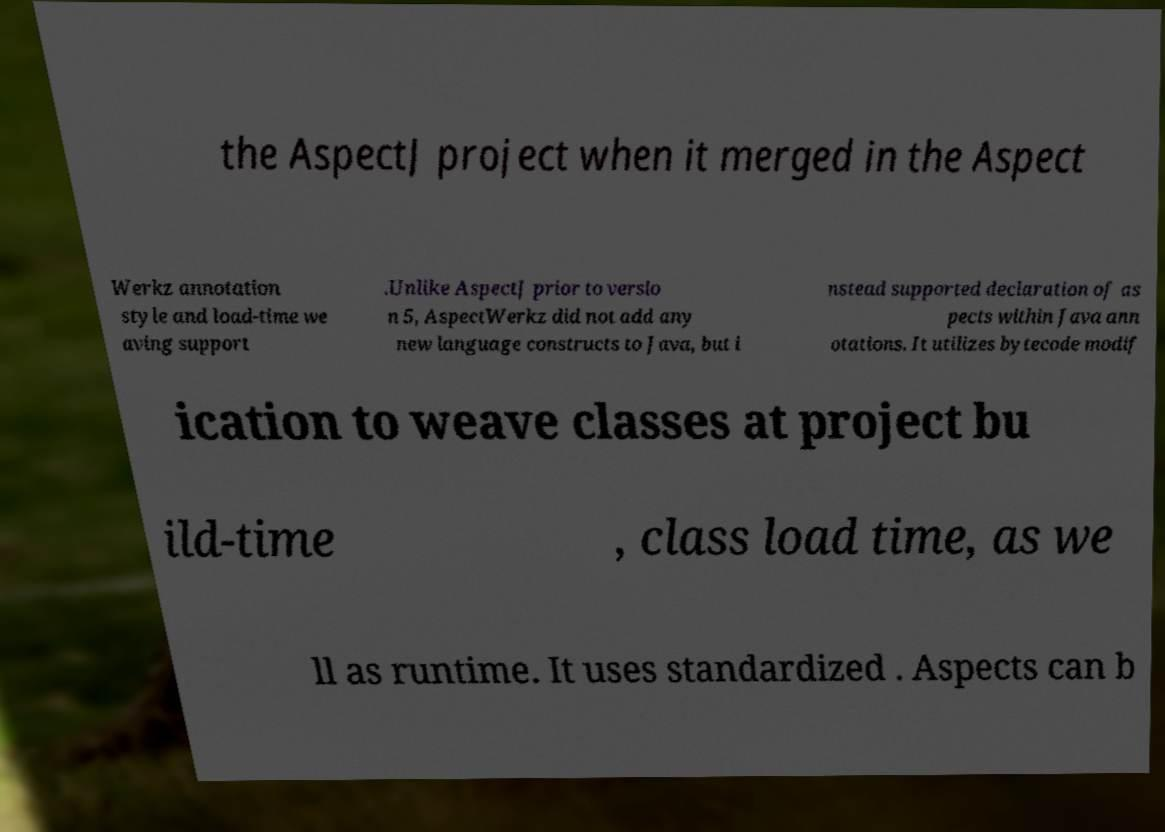I need the written content from this picture converted into text. Can you do that? the AspectJ project when it merged in the Aspect Werkz annotation style and load-time we aving support .Unlike AspectJ prior to versio n 5, AspectWerkz did not add any new language constructs to Java, but i nstead supported declaration of as pects within Java ann otations. It utilizes bytecode modif ication to weave classes at project bu ild-time , class load time, as we ll as runtime. It uses standardized . Aspects can b 